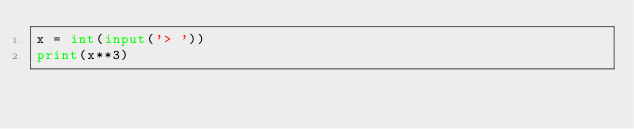Convert code to text. <code><loc_0><loc_0><loc_500><loc_500><_Python_>x = int(input('> '))
print(x**3)</code> 